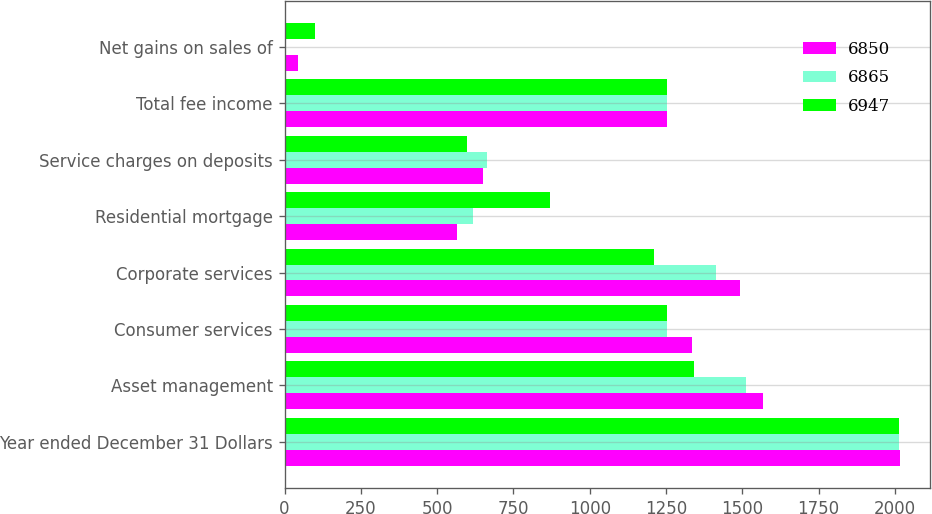Convert chart to OTSL. <chart><loc_0><loc_0><loc_500><loc_500><stacked_bar_chart><ecel><fcel>Year ended December 31 Dollars<fcel>Asset management<fcel>Consumer services<fcel>Corporate services<fcel>Residential mortgage<fcel>Service charges on deposits<fcel>Total fee income<fcel>Net gains on sales of<nl><fcel>6850<fcel>2015<fcel>1567<fcel>1335<fcel>1491<fcel>566<fcel>651<fcel>1253<fcel>43<nl><fcel>6865<fcel>2014<fcel>1513<fcel>1254<fcel>1415<fcel>618<fcel>662<fcel>1253<fcel>4<nl><fcel>6947<fcel>2013<fcel>1342<fcel>1253<fcel>1210<fcel>871<fcel>597<fcel>1253<fcel>99<nl></chart> 